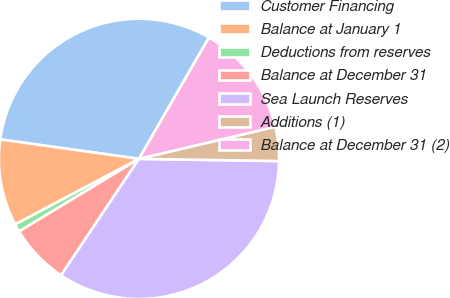Convert chart. <chart><loc_0><loc_0><loc_500><loc_500><pie_chart><fcel>Customer Financing<fcel>Balance at January 1<fcel>Deductions from reserves<fcel>Balance at December 31<fcel>Sea Launch Reserves<fcel>Additions (1)<fcel>Balance at December 31 (2)<nl><fcel>31.11%<fcel>9.97%<fcel>0.91%<fcel>6.95%<fcel>34.13%<fcel>3.93%<fcel>12.99%<nl></chart> 